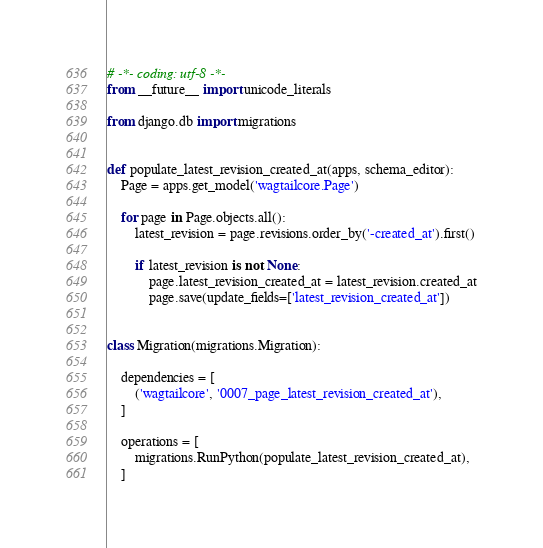<code> <loc_0><loc_0><loc_500><loc_500><_Python_># -*- coding: utf-8 -*-
from __future__ import unicode_literals

from django.db import migrations


def populate_latest_revision_created_at(apps, schema_editor):
    Page = apps.get_model('wagtailcore.Page')

    for page in Page.objects.all():
        latest_revision = page.revisions.order_by('-created_at').first()

        if latest_revision is not None:
            page.latest_revision_created_at = latest_revision.created_at
            page.save(update_fields=['latest_revision_created_at'])


class Migration(migrations.Migration):

    dependencies = [
        ('wagtailcore', '0007_page_latest_revision_created_at'),
    ]

    operations = [
        migrations.RunPython(populate_latest_revision_created_at),
    ]
</code> 